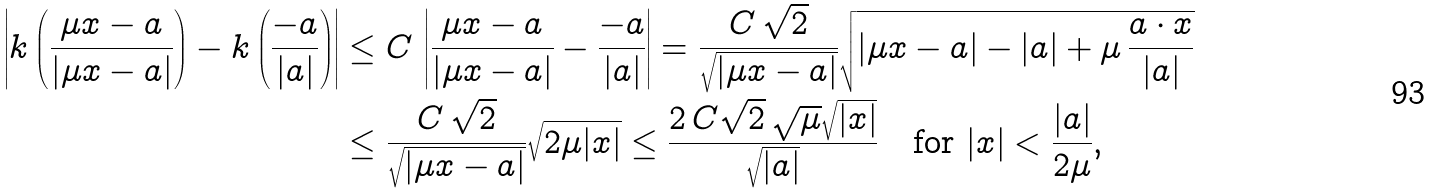<formula> <loc_0><loc_0><loc_500><loc_500>\left | k \left ( \frac { \mu x - a } { | \mu x - a | } \right ) - k \left ( \frac { - a } { | a | } \right ) \right | & \leq C \, \left | \frac { \mu x - a } { | \mu x - a | } - \frac { - a } { | a | } \right | = \frac { C \, \sqrt { 2 } } { \sqrt { | \mu x - a | } } \sqrt { | \mu x - a | - | a | + \mu \, \frac { a \cdot x } { | a | } } \\ & \leq \frac { C \, \sqrt { 2 } } { \sqrt { | \mu x - a | } } \sqrt { 2 \mu | x | } \leq \frac { 2 \, C \sqrt { 2 } \, \sqrt { \mu } \sqrt { | x | } } { \sqrt { | a | } } \quad \text {for } | x | < \frac { | a | } { 2 \mu } ,</formula> 